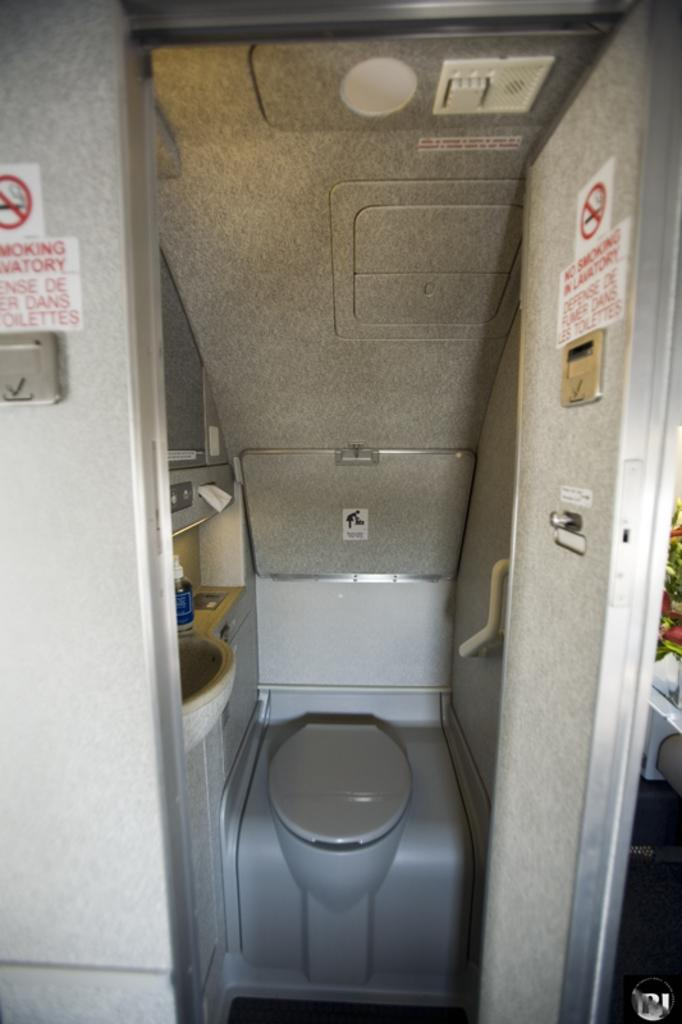<image>
Give a short and clear explanation of the subsequent image. Bathroom in an airplane with a sign that says No Smoking. 